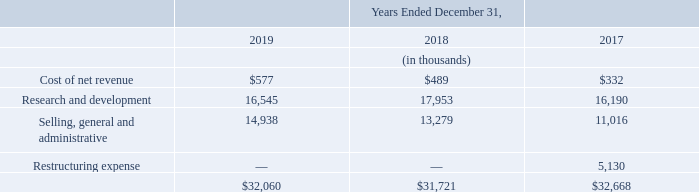Stock-Based Compensation
The Company recognizes stock-based compensation expense in the consolidated statements of operations, based on the department to which the related employee reports, as follows: The Company recognizes stock-based compensation expense in the consolidated statements of operations, based on the department to which the related employee reports, as follows:
The total unrecognized compensation cost related to performance-based restricted stock units as of December 31, 2019 was $3.6 million, and the weighted average period over which these equity awards are expected to vest is 1.6 years. The total unrecognized compensation cost related to unvested stock options as of December 31, 2019 was $2.0 million, and the weighted average period over which these equity awards are expected to vest is 2.30 years.
What was the respective Selling, general and administrative expense in 2019, 2018 and 2017?
Answer scale should be: thousand. 14,938, 13,279, 11,016. What was the respective research and development expense in 2019, 2018 and 2017?
Answer scale should be: thousand. 16,545, 17,953, 16,190. What was the respective Cost of net revenue in 2019, 2018 and 2017?
Answer scale should be: thousand. $577, $489, $332. What was the change in Cost of net revenue from 2018 to 2019?
Answer scale should be: thousand. 577 - 489
Answer: 88. What was the average Research and development between 2017-2019?
Answer scale should be: thousand. (16,545 + 17,953 + 16,190) / 3
Answer: 16896. In which year was Restructuring expense 0 thousands? Locate and analyze restructuring expense in row 7
answer: 2019, 2018. 